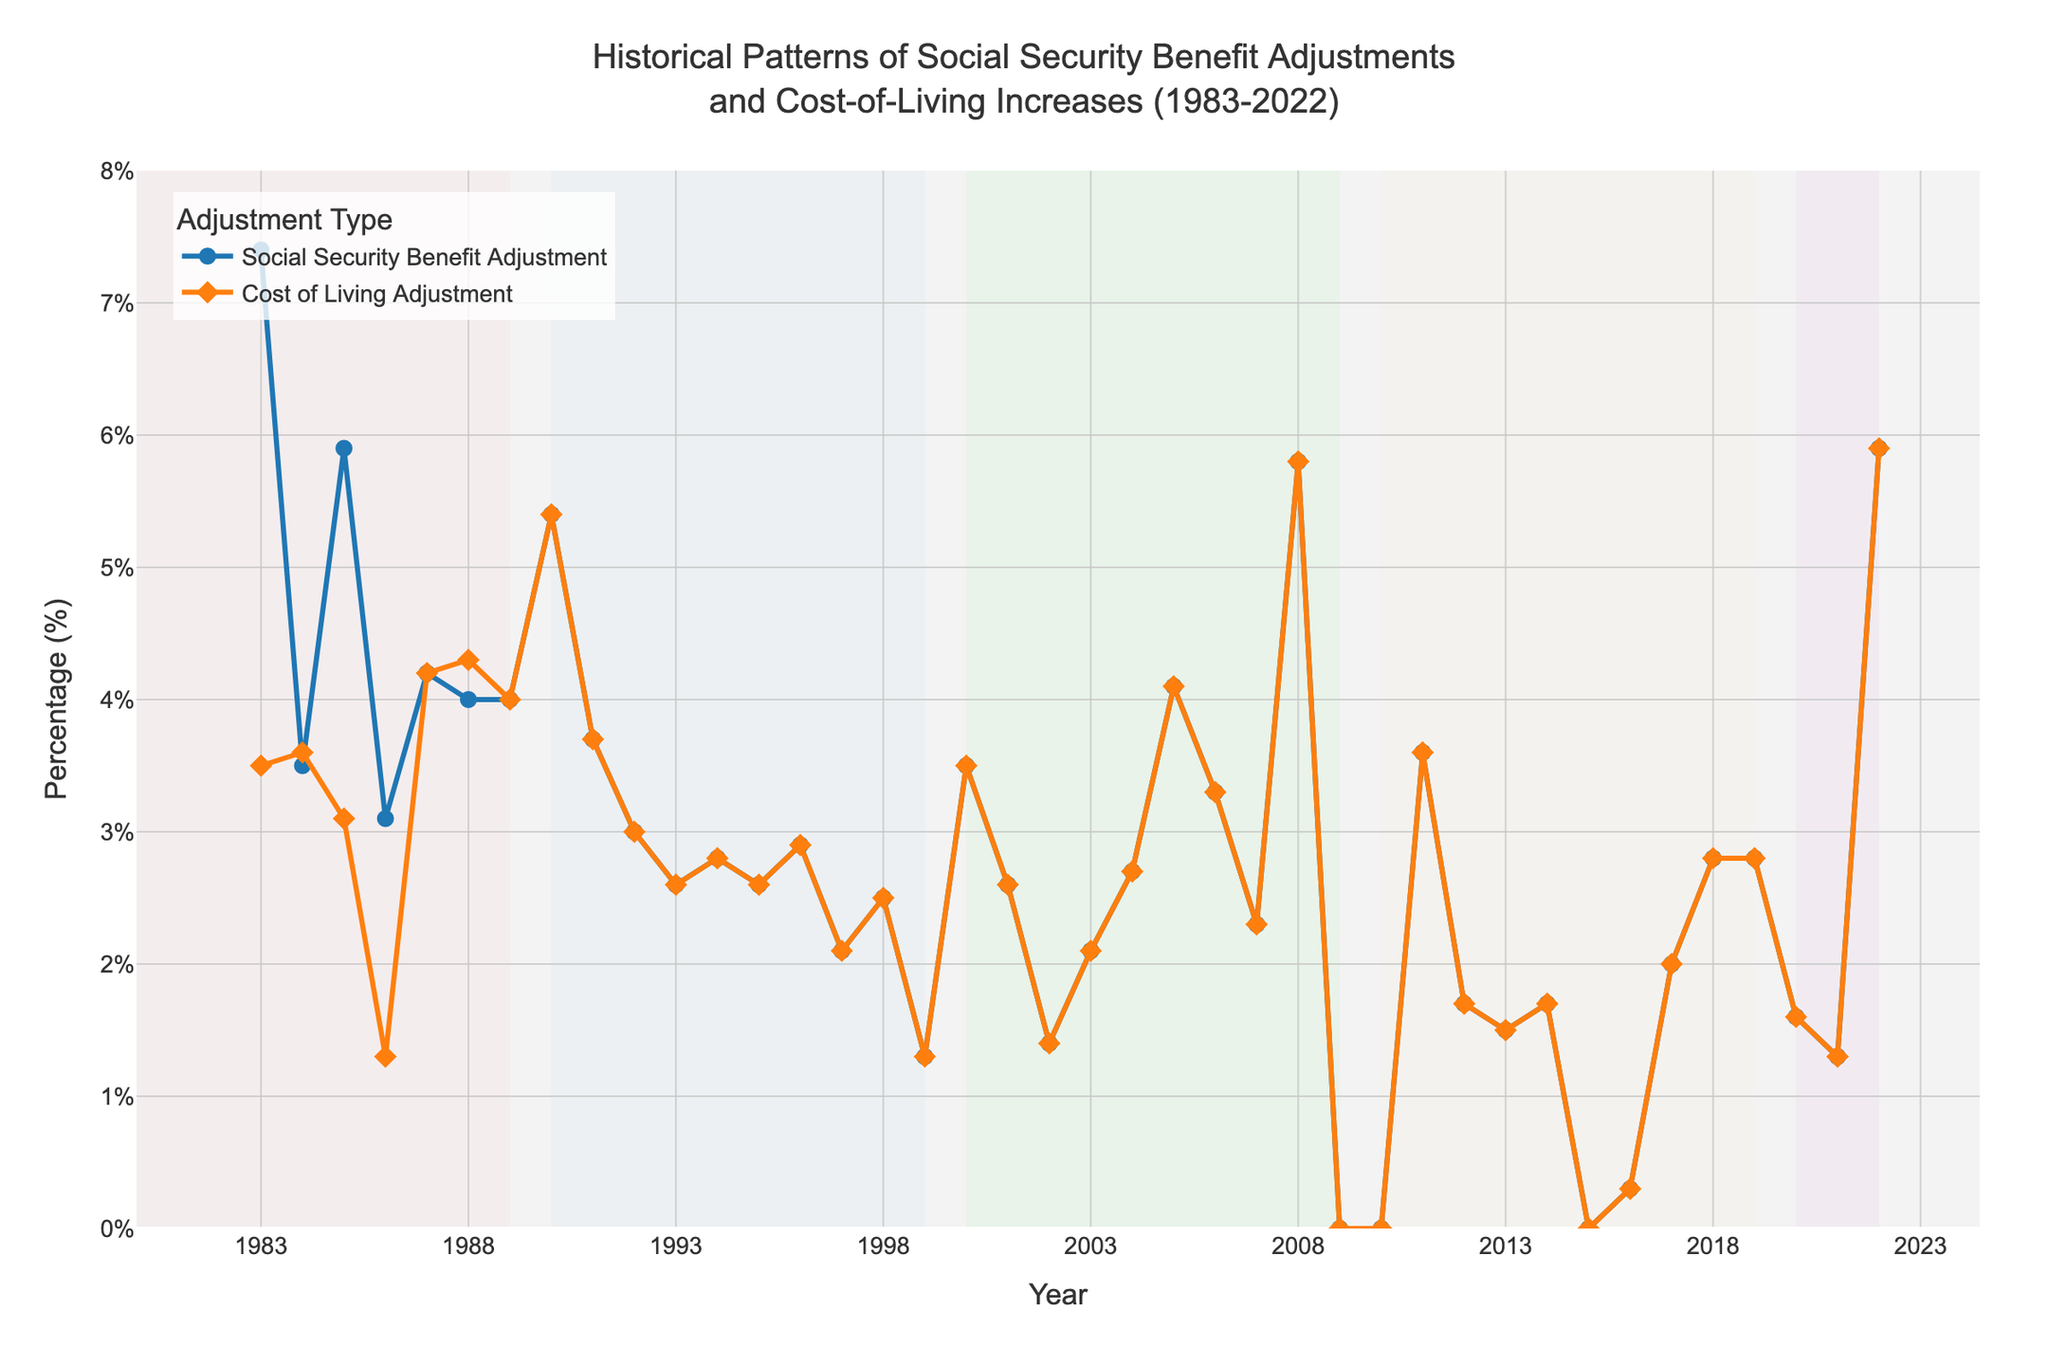How many years had a 0% Social Security Benefit Adjustment? By carefully examining the visual drop to 0% on the y-axis, it is evident that the years with a 0% adjustment were 2009, 2010, and 2015. Counting these instances gives us the total number of years with a 0% adjustment.
Answer: 3 What's the color of the line representing Social Security Benefit Adjustments? By looking at the figure, we see that the Social Security Benefit Adjustments line is represented in a blue color.
Answer: Blue What is the highest Social Security Benefit Adjustment percentage shown in the figure? The highest point on the blue line representing Social Security Benefit Adjustments is at 7.4% in the year 1983.
Answer: 7.4% Between which years did the longest consecutive decline in Social Security Benefit Adjustments occur? By following the downward trends in the blue line, the longest consecutive decline happens between 1985 to 1986, where it drops from 5.9% to 3.1%.
Answer: 1985 to 1986 How many years had either Social Security Benefit Adjustment or Cost of Living Adjustment at 5% or higher? By inspecting the y-axis intervals and cross-referencing with both lines, we see hits above 5% in the years 1983, 1985, 1990, 2008, and 2022. Totaling these instances gives us a count.
Answer: 5 In which decade was the average Cost of Living Adjustment percentage the lowest? By isolating each decade and averaging the orange line's values within those ranges, it's observed that the 2010s (2010-2019) had the lowest average Cost of Living Adjustment.
Answer: 2010s Which year has the same percentage for both Social Security Benefit Adjustment and Cost of Living Adjustment, and what is that percentage? By identifying where the blue and orange lines overlap perfectly in both direction and value, the year 2022 matches with a percentage of 5.9%.
Answer: 2022, 5.9% How frequently do Social Security Benefit Adjustments and Cost of Living Adjustments percentages match in the dataset? By counting intersections or overlapping points between the blue and orange lines, both metrics have matched eight times during the full date range.
Answer: 8 What was the difference in Social Security Benefit Adjustment between 1987 and 1988? By reviewing the blue line between these years, it rises from 4.2% in 1987 to 4.0% in 1988, resulting in a decrease of -0.2%.
Answer: -0.2% When do the Cost of Living Adjustment and Social Security Benefit Adjustment both first reach 4% or higher? The first occurrence in the plot where both lines cross or meet at 4% or higher happens in the year 1987.
Answer: 1987 